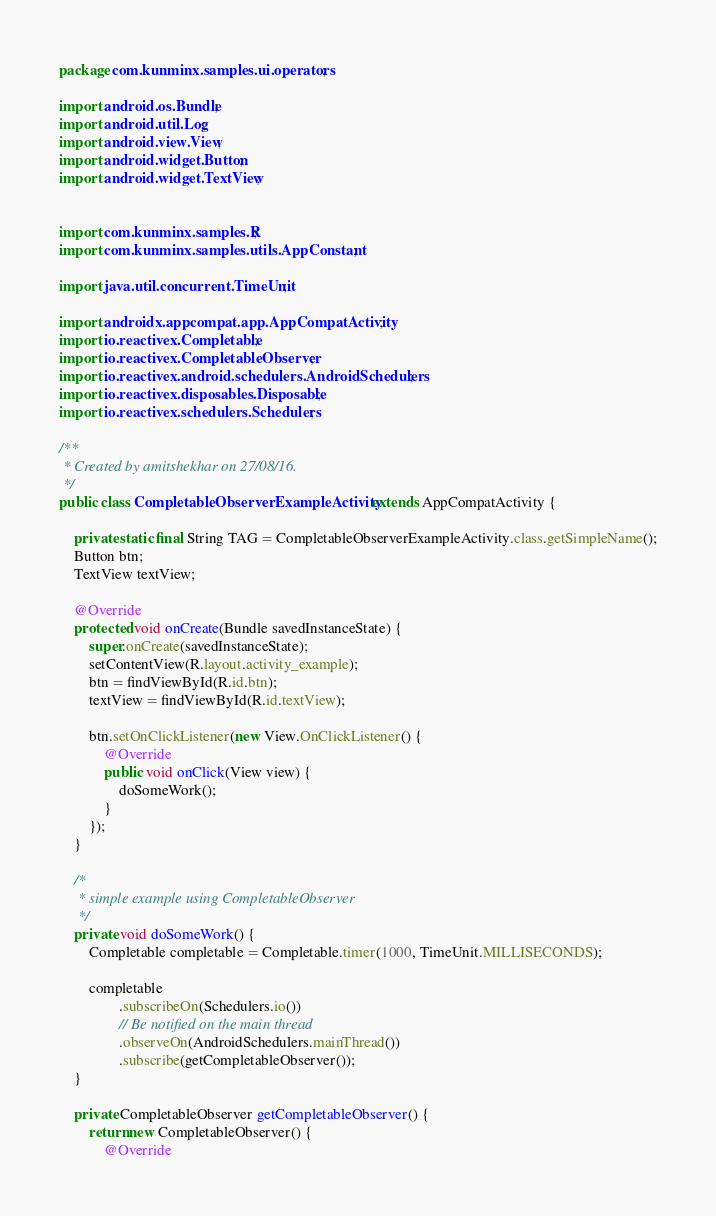Convert code to text. <code><loc_0><loc_0><loc_500><loc_500><_Java_>package com.kunminx.samples.ui.operators;

import android.os.Bundle;
import android.util.Log;
import android.view.View;
import android.widget.Button;
import android.widget.TextView;


import com.kunminx.samples.R;
import com.kunminx.samples.utils.AppConstant;

import java.util.concurrent.TimeUnit;

import androidx.appcompat.app.AppCompatActivity;
import io.reactivex.Completable;
import io.reactivex.CompletableObserver;
import io.reactivex.android.schedulers.AndroidSchedulers;
import io.reactivex.disposables.Disposable;
import io.reactivex.schedulers.Schedulers;

/**
 * Created by amitshekhar on 27/08/16.
 */
public class CompletableObserverExampleActivity extends AppCompatActivity {

    private static final String TAG = CompletableObserverExampleActivity.class.getSimpleName();
    Button btn;
    TextView textView;

    @Override
    protected void onCreate(Bundle savedInstanceState) {
        super.onCreate(savedInstanceState);
        setContentView(R.layout.activity_example);
        btn = findViewById(R.id.btn);
        textView = findViewById(R.id.textView);

        btn.setOnClickListener(new View.OnClickListener() {
            @Override
            public void onClick(View view) {
                doSomeWork();
            }
        });
    }

    /*
     * simple example using CompletableObserver
     */
    private void doSomeWork() {
        Completable completable = Completable.timer(1000, TimeUnit.MILLISECONDS);

        completable
                .subscribeOn(Schedulers.io())
                // Be notified on the main thread
                .observeOn(AndroidSchedulers.mainThread())
                .subscribe(getCompletableObserver());
    }

    private CompletableObserver getCompletableObserver() {
        return new CompletableObserver() {
            @Override</code> 